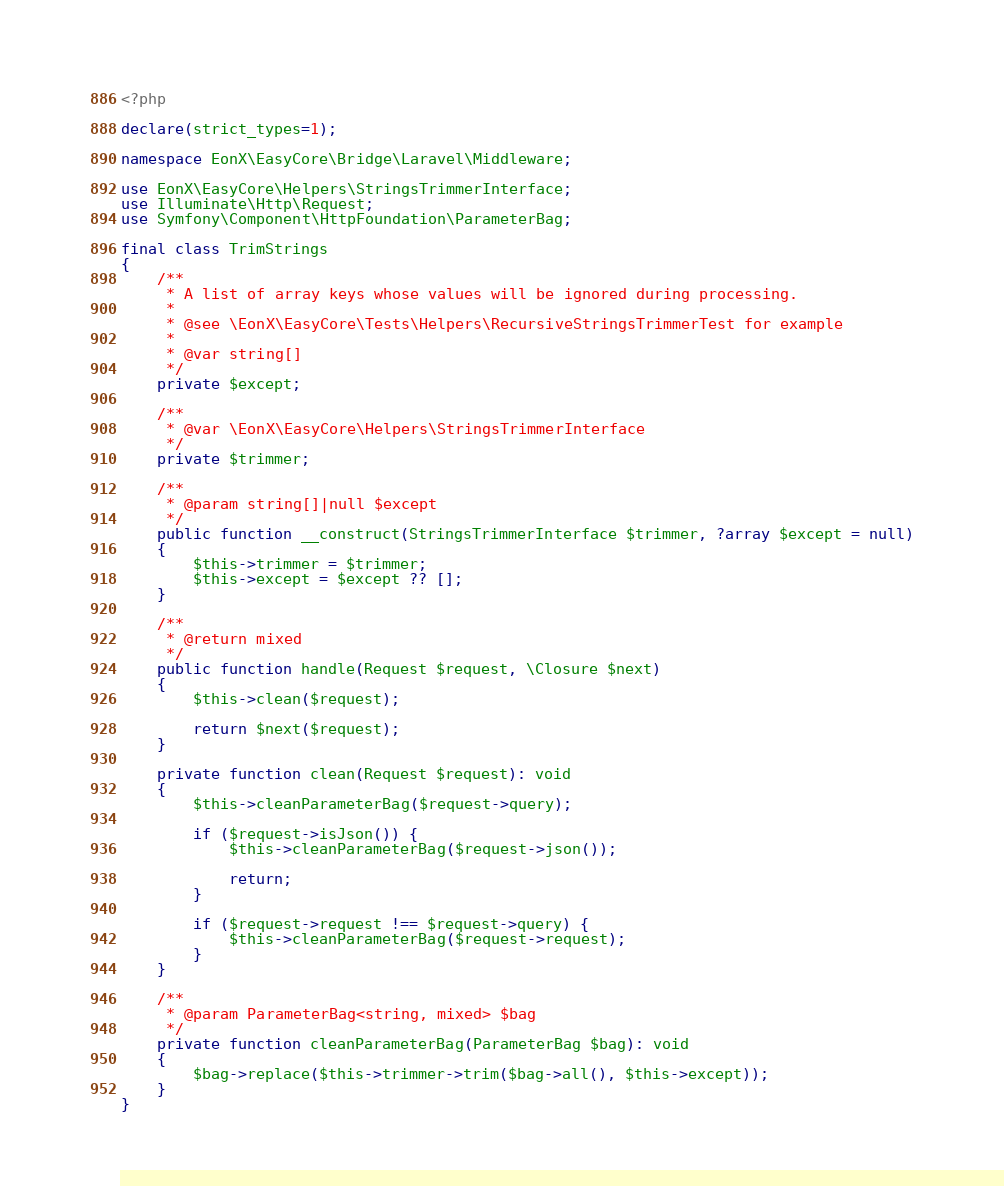Convert code to text. <code><loc_0><loc_0><loc_500><loc_500><_PHP_><?php

declare(strict_types=1);

namespace EonX\EasyCore\Bridge\Laravel\Middleware;

use EonX\EasyCore\Helpers\StringsTrimmerInterface;
use Illuminate\Http\Request;
use Symfony\Component\HttpFoundation\ParameterBag;

final class TrimStrings
{
    /**
     * A list of array keys whose values will be ignored during processing.
     *
     * @see \EonX\EasyCore\Tests\Helpers\RecursiveStringsTrimmerTest for example
     *
     * @var string[]
     */
    private $except;

    /**
     * @var \EonX\EasyCore\Helpers\StringsTrimmerInterface
     */
    private $trimmer;

    /**
     * @param string[]|null $except
     */
    public function __construct(StringsTrimmerInterface $trimmer, ?array $except = null)
    {
        $this->trimmer = $trimmer;
        $this->except = $except ?? [];
    }

    /**
     * @return mixed
     */
    public function handle(Request $request, \Closure $next)
    {
        $this->clean($request);

        return $next($request);
    }

    private function clean(Request $request): void
    {
        $this->cleanParameterBag($request->query);

        if ($request->isJson()) {
            $this->cleanParameterBag($request->json());

            return;
        }

        if ($request->request !== $request->query) {
            $this->cleanParameterBag($request->request);
        }
    }

    /**
     * @param ParameterBag<string, mixed> $bag
     */
    private function cleanParameterBag(ParameterBag $bag): void
    {
        $bag->replace($this->trimmer->trim($bag->all(), $this->except));
    }
}
</code> 